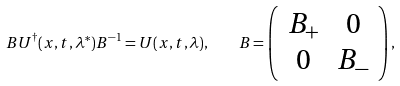<formula> <loc_0><loc_0><loc_500><loc_500>B U ^ { \dag } ( x , t , \lambda ^ { * } ) B ^ { - 1 } = U ( x , t , \lambda ) , \quad B = \left ( \begin{array} { c c } B _ { + } & 0 \\ 0 & B _ { - } \end{array} \right ) ,</formula> 